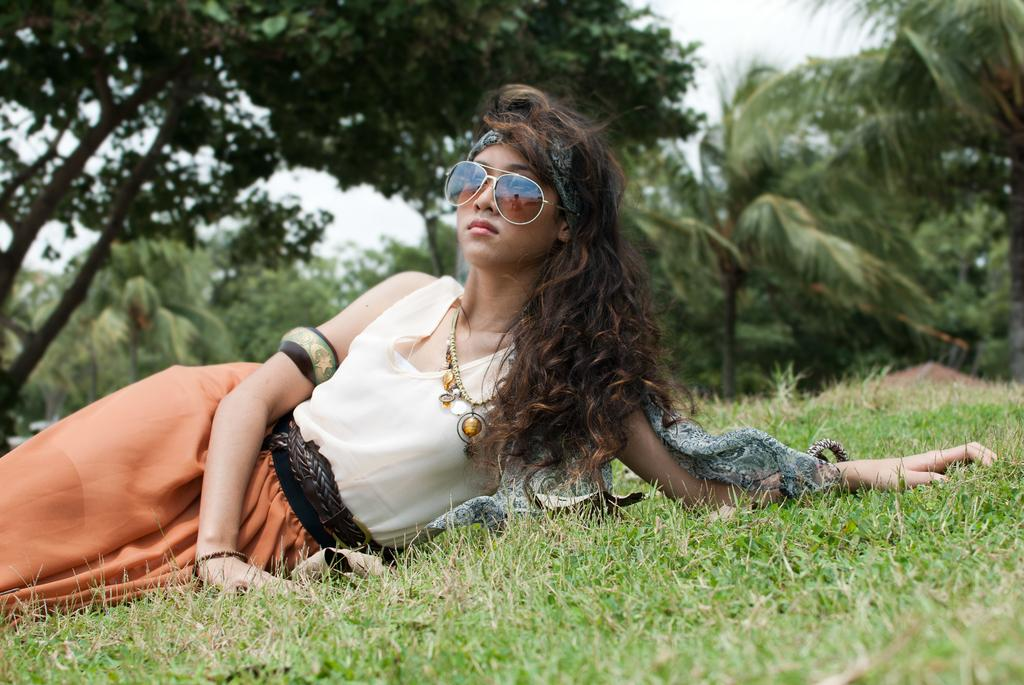What is the girl in the image doing? The girl is lying on the ground in the image. What type of surface is the girl lying on? There is grass at the bottom of the image, which is the surface the girl is lying on. What is the girl wearing that is covering her eyes? The girl is wearing shades in the image. What can be seen in the background of the image? There are trees in the background of the image. What is visible at the top of the image? The sky is visible at the top of the image. What type of flower is the girl holding in her hand in the image? There is no flower visible in the girl's hand in the image. What is the girl eating in the image? The image does not show the girl eating anything, including celery. 